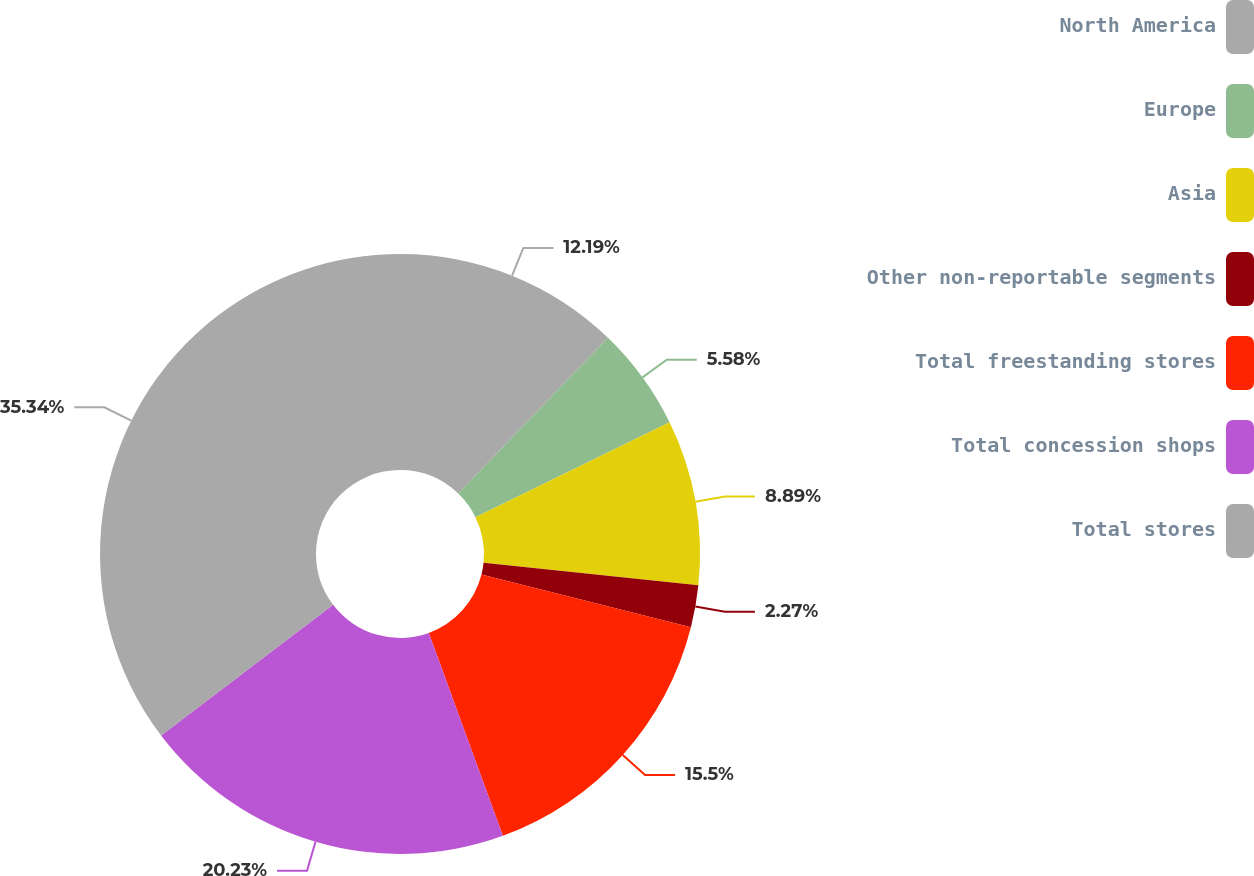Convert chart. <chart><loc_0><loc_0><loc_500><loc_500><pie_chart><fcel>North America<fcel>Europe<fcel>Asia<fcel>Other non-reportable segments<fcel>Total freestanding stores<fcel>Total concession shops<fcel>Total stores<nl><fcel>12.19%<fcel>5.58%<fcel>8.89%<fcel>2.27%<fcel>15.5%<fcel>20.23%<fcel>35.34%<nl></chart> 